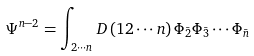Convert formula to latex. <formula><loc_0><loc_0><loc_500><loc_500>\Psi ^ { n - 2 } = \int _ { 2 \cdots n } D \left ( 1 2 \cdots n \right ) \Phi _ { \bar { 2 } } \Phi _ { \bar { 3 } } \cdots \Phi _ { \bar { n } }</formula> 